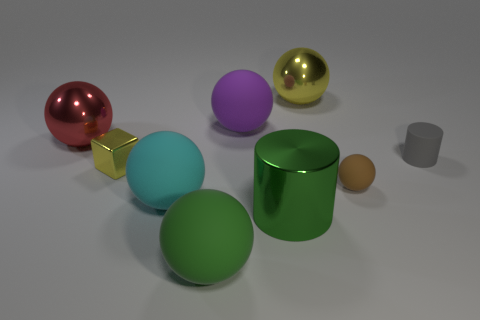How many metallic cylinders have the same size as the brown rubber object?
Ensure brevity in your answer.  0. Is the number of small matte cylinders to the left of the big green matte object the same as the number of large green blocks?
Ensure brevity in your answer.  Yes. How many small objects are both behind the brown thing and on the left side of the tiny gray cylinder?
Provide a short and direct response. 1. There is a large metal object that is in front of the brown matte object; does it have the same shape as the small gray thing?
Your answer should be very brief. Yes. What is the material of the yellow object that is the same size as the brown ball?
Offer a very short reply. Metal. Are there an equal number of large rubber spheres to the right of the tiny gray matte thing and red balls in front of the purple sphere?
Your response must be concise. No. There is a yellow metallic thing that is in front of the large metal thing that is to the left of the large green rubber object; what number of metal blocks are in front of it?
Make the answer very short. 0. There is a metal cube; is it the same color as the shiny ball that is right of the red metal ball?
Give a very brief answer. Yes. What is the size of the brown ball that is the same material as the tiny gray cylinder?
Keep it short and to the point. Small. Is the number of big green cylinders in front of the big cyan matte object greater than the number of small purple metallic things?
Give a very brief answer. Yes. 